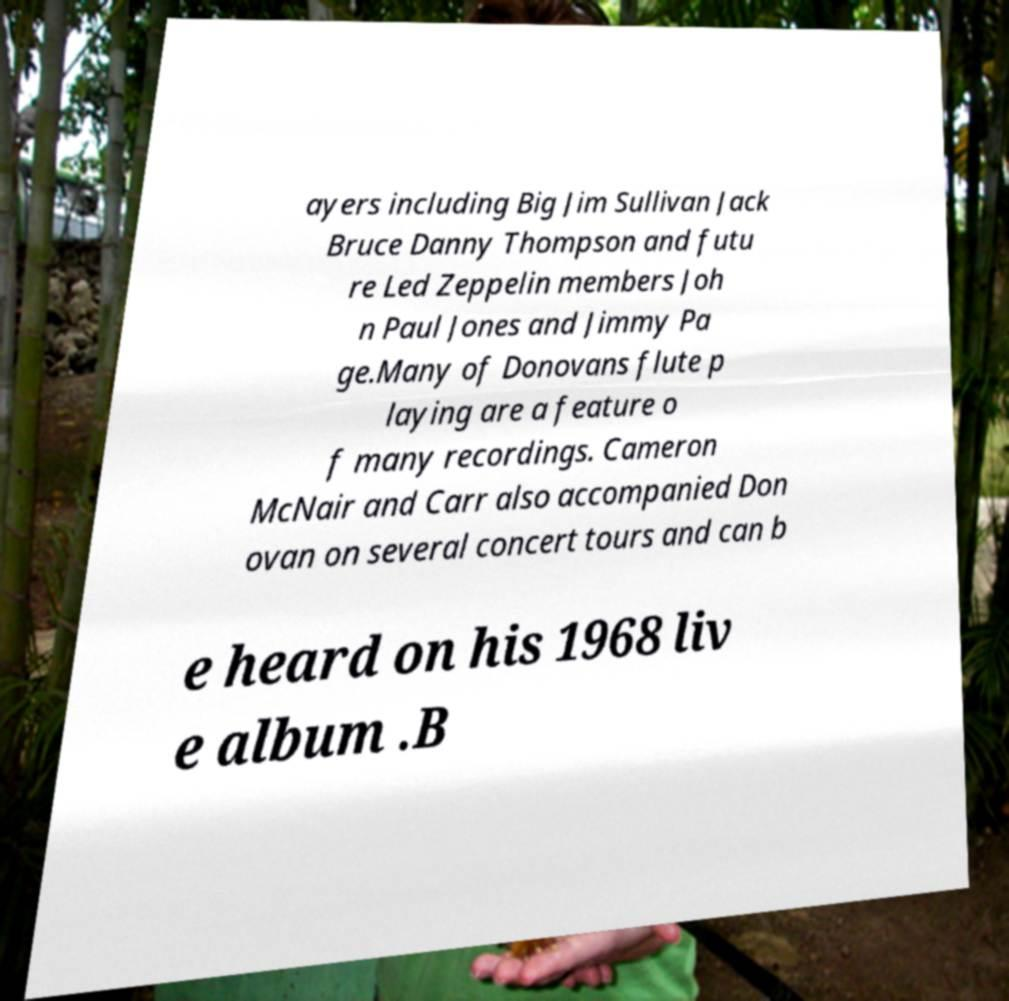Can you accurately transcribe the text from the provided image for me? ayers including Big Jim Sullivan Jack Bruce Danny Thompson and futu re Led Zeppelin members Joh n Paul Jones and Jimmy Pa ge.Many of Donovans flute p laying are a feature o f many recordings. Cameron McNair and Carr also accompanied Don ovan on several concert tours and can b e heard on his 1968 liv e album .B 